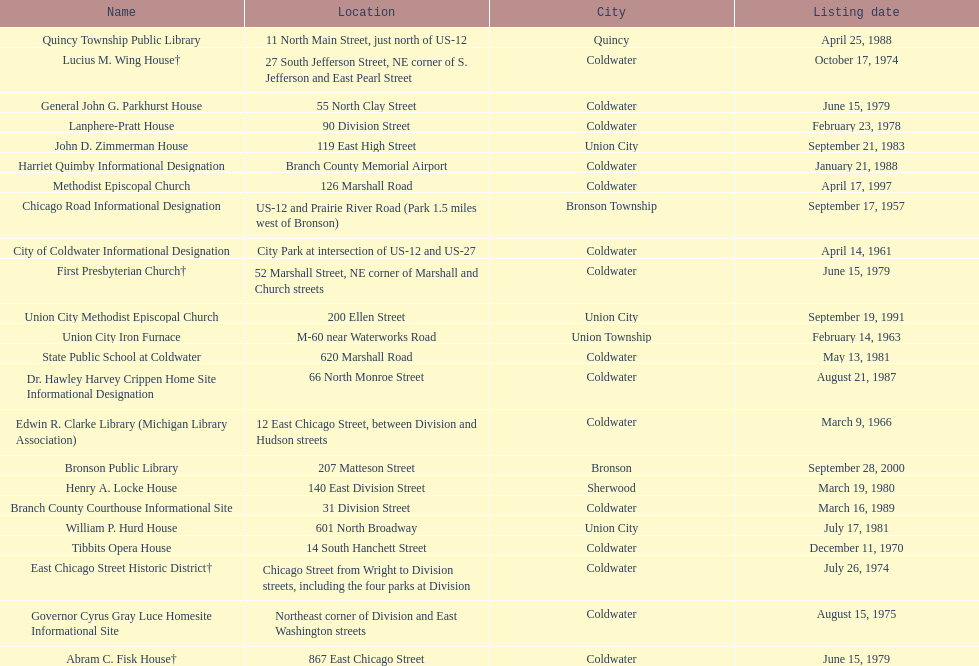How many historic sites are listed in coldwater? 15. 